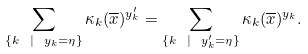<formula> <loc_0><loc_0><loc_500><loc_500>\sum _ { \{ k \ | \ y _ { k } = \eta \} } \kappa _ { k } ( { \overline { x } } ) ^ { y _ { k } ^ { \prime } } = \sum _ { \{ k \ | \ y _ { k } ^ { \prime } = \eta \} } \kappa _ { k } ( { \overline { x } } ) ^ { y _ { k } } .</formula> 